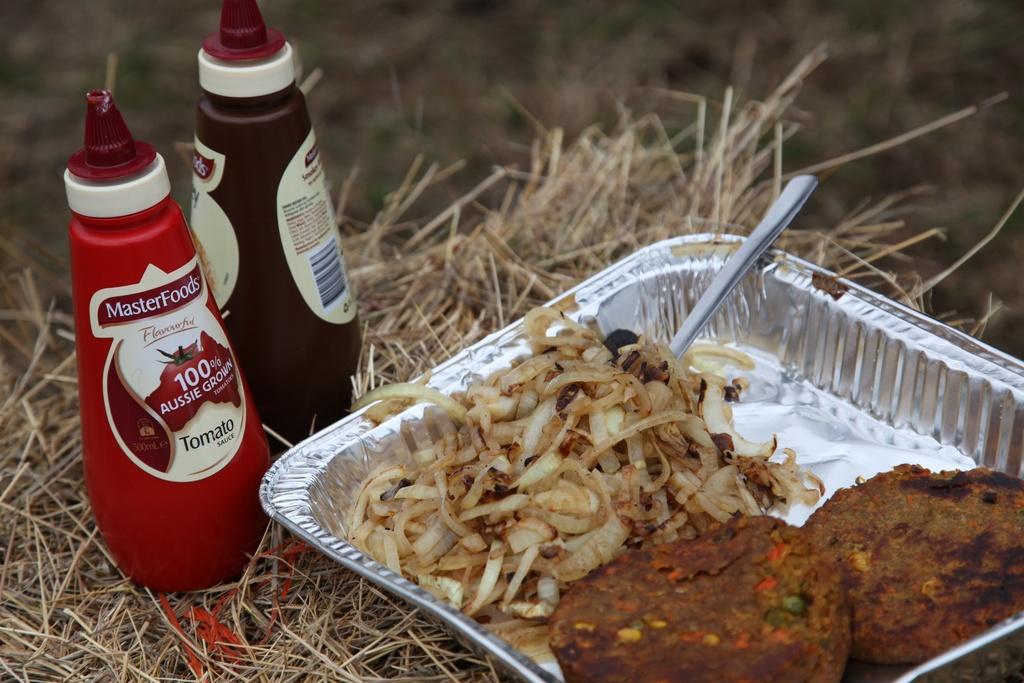What is 100%?
Your answer should be compact. Aussie grown. 